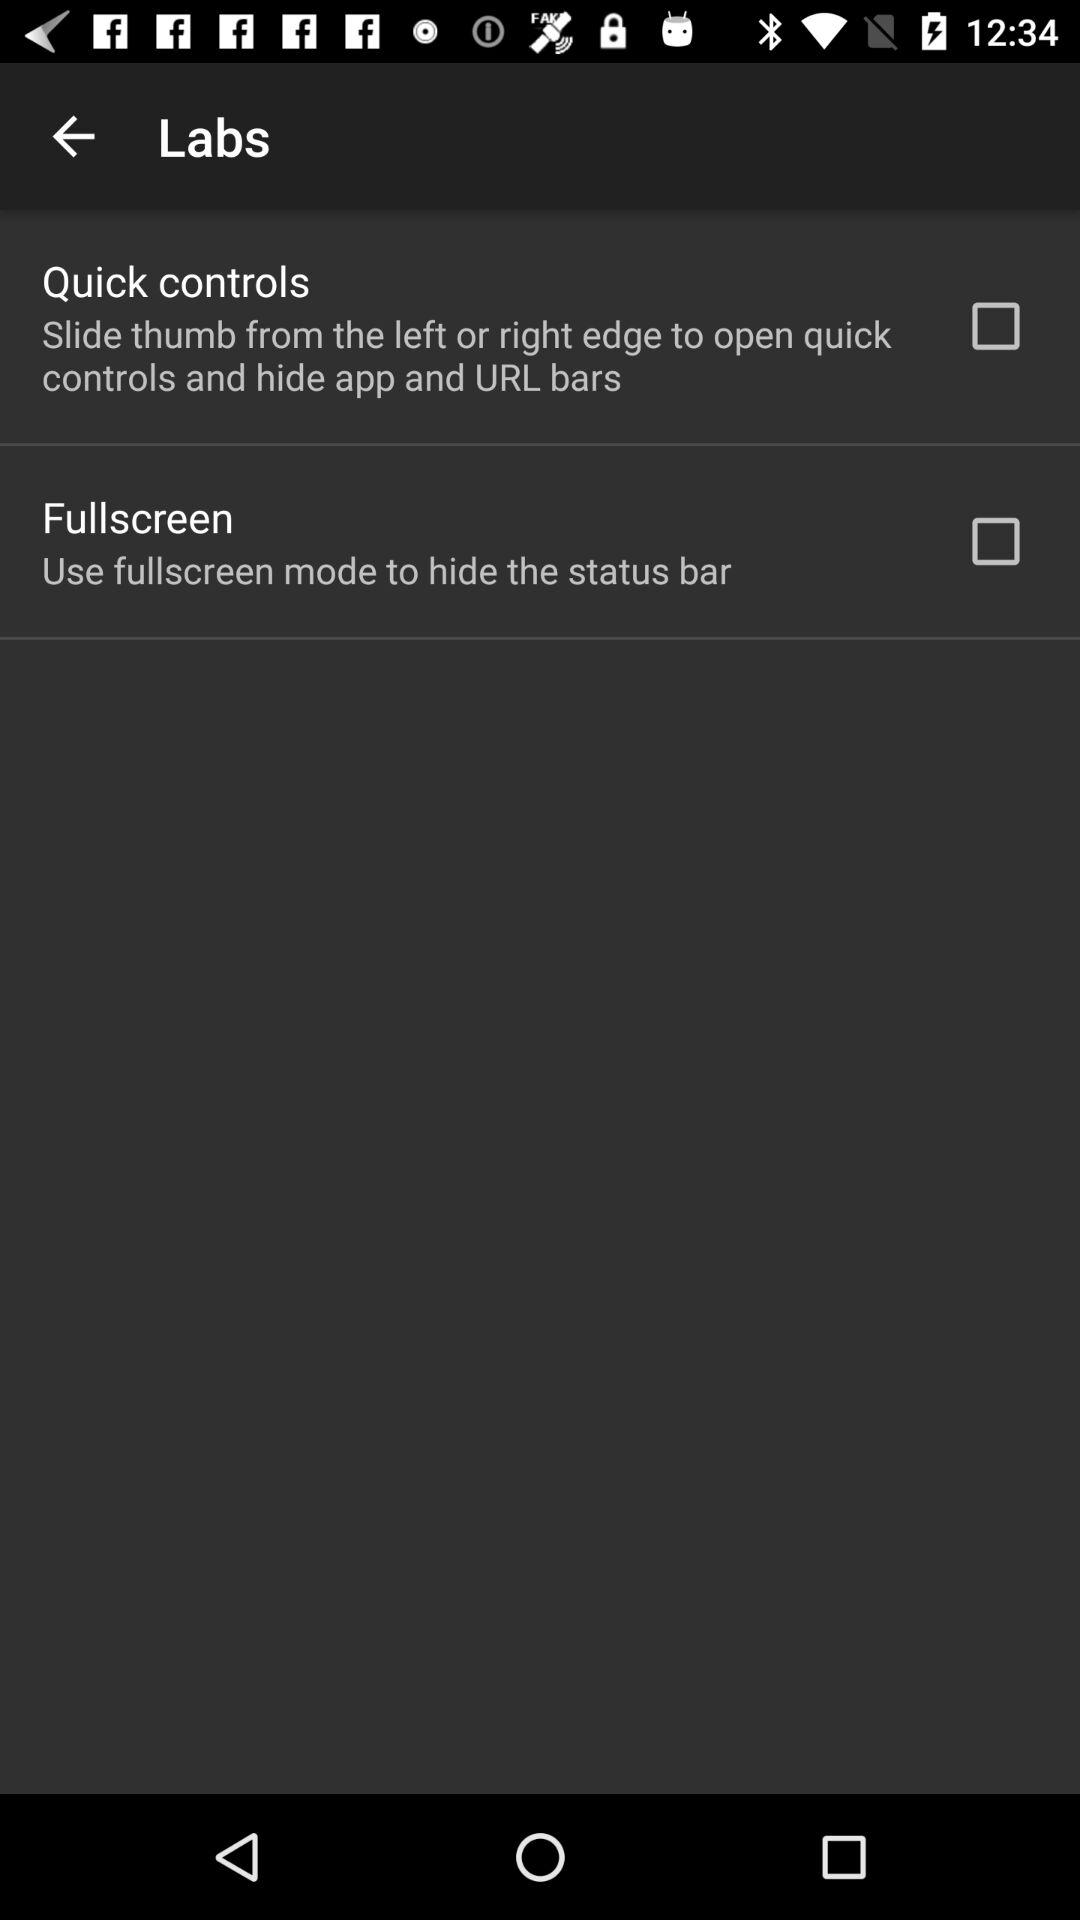What is the current status of the "Quick controls"? The status is "off". 